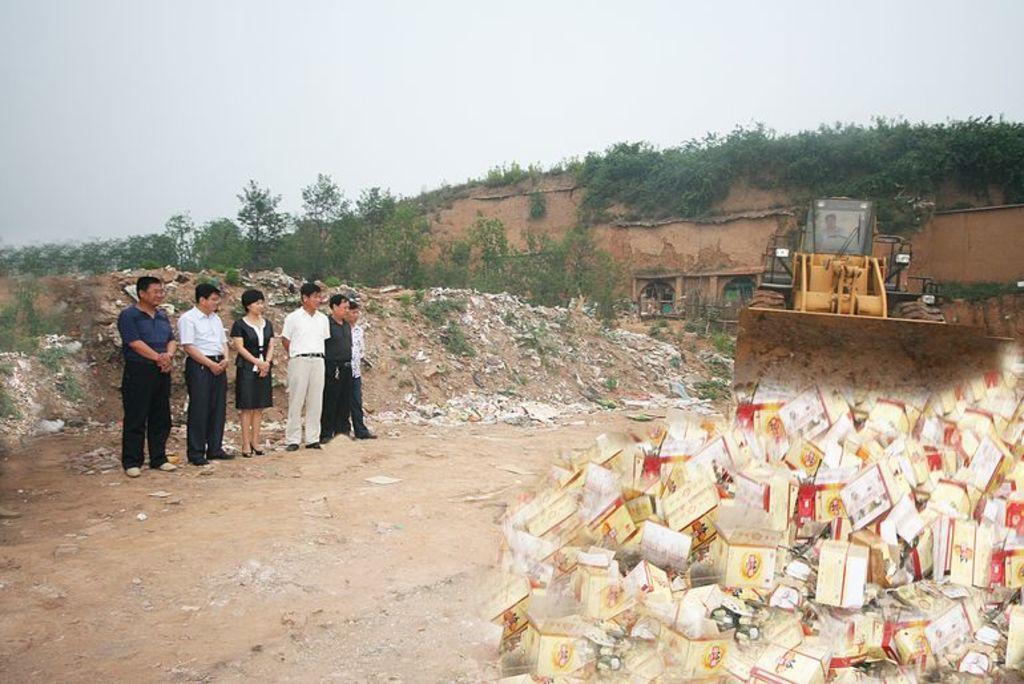In one or two sentences, can you explain what this image depicts? In this picture we can see a few boxes. There are a few people standing on the ground. We can see a person sitting in a vehicle. There are plants, other objects and the sky. 